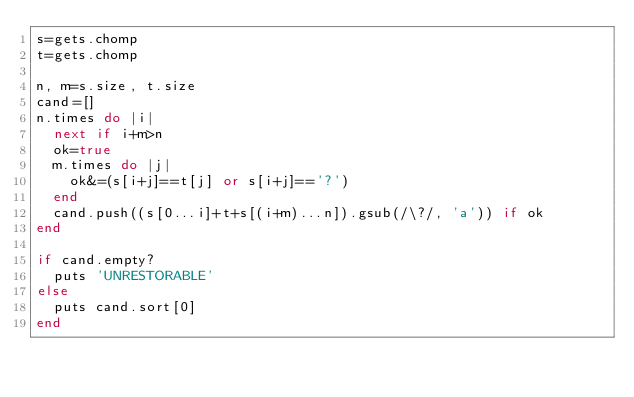Convert code to text. <code><loc_0><loc_0><loc_500><loc_500><_Ruby_>s=gets.chomp
t=gets.chomp

n, m=s.size, t.size
cand=[]
n.times do |i|
  next if i+m>n
  ok=true
  m.times do |j|
    ok&=(s[i+j]==t[j] or s[i+j]=='?')
  end
  cand.push((s[0...i]+t+s[(i+m)...n]).gsub(/\?/, 'a')) if ok
end

if cand.empty?
  puts 'UNRESTORABLE'
else
  puts cand.sort[0]
end</code> 